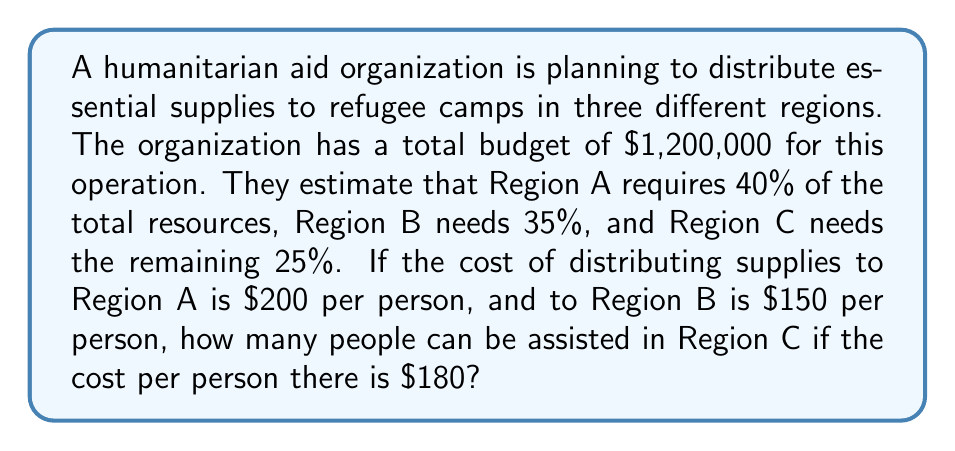What is the answer to this math problem? Let's break this problem down step by step:

1. Calculate the budget allocation for each region:
   Region A: $1,200,000 \times 40\% = $480,000
   Region B: $1,200,000 \times 35\% = $420,000
   Region C: $1,200,000 \times 25\% = $300,000

2. Calculate the number of people that can be assisted in Regions A and B:
   Region A: $\frac{$480,000}{$200\text{ per person}} = 2,400$ people
   Region B: $\frac{$420,000}{$150\text{ per person}} = 2,800$ people

3. Calculate the number of people that can be assisted in Region C:
   Budget for Region C: $300,000
   Cost per person in Region C: $180

   Let $x$ be the number of people that can be assisted in Region C.
   We can set up the equation:
   
   $$180x = 300,000$$

4. Solve for $x$:
   $$x = \frac{300,000}{180} = 1,666.67$$

5. Since we can't assist a fraction of a person, we round down to the nearest whole number:
   $x = 1,666$ people

Therefore, 1,666 people can be assisted in Region C.
Answer: 1,666 people 